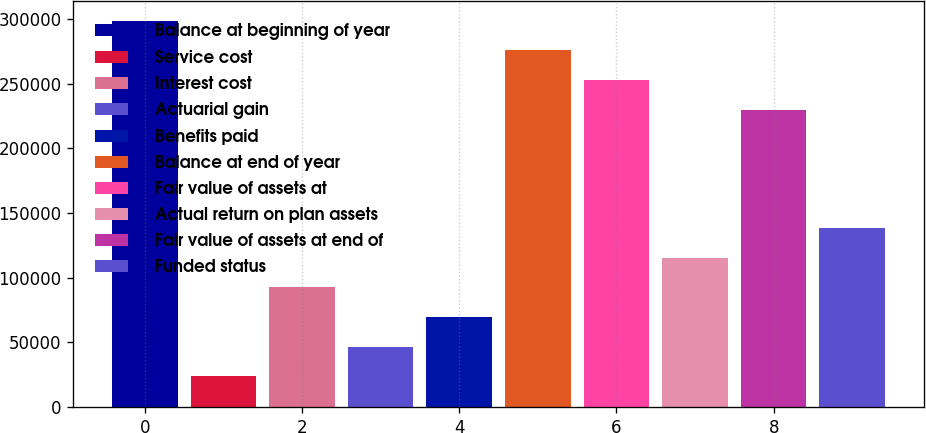<chart> <loc_0><loc_0><loc_500><loc_500><bar_chart><fcel>Balance at beginning of year<fcel>Service cost<fcel>Interest cost<fcel>Actuarial gain<fcel>Benefits paid<fcel>Balance at end of year<fcel>Fair value of assets at<fcel>Actual return on plan assets<fcel>Fair value of assets at end of<fcel>Funded status<nl><fcel>298696<fcel>23760.3<fcel>92494.2<fcel>46671.6<fcel>69582.9<fcel>275785<fcel>252873<fcel>115406<fcel>229962<fcel>138317<nl></chart> 